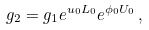Convert formula to latex. <formula><loc_0><loc_0><loc_500><loc_500>g _ { 2 } = g _ { 1 } e ^ { u _ { 0 } L _ { 0 } } e ^ { \phi _ { 0 } U _ { 0 } } \, ,</formula> 